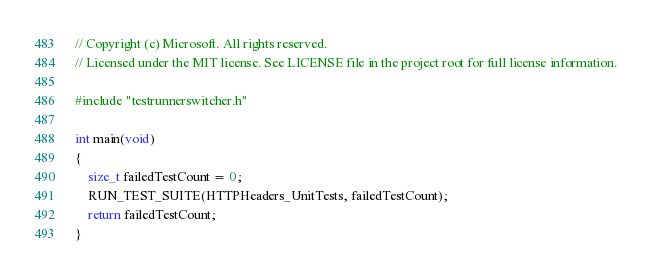<code> <loc_0><loc_0><loc_500><loc_500><_C_>// Copyright (c) Microsoft. All rights reserved.
// Licensed under the MIT license. See LICENSE file in the project root for full license information.

#include "testrunnerswitcher.h"

int main(void)
{
    size_t failedTestCount = 0;
    RUN_TEST_SUITE(HTTPHeaders_UnitTests, failedTestCount);
    return failedTestCount;
}
</code> 